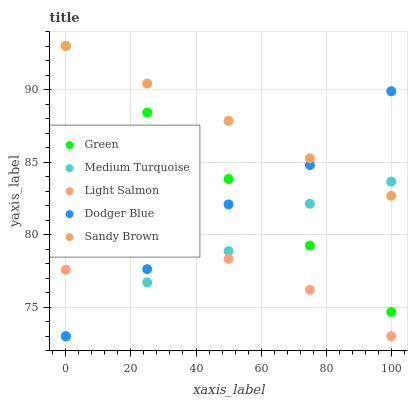Does Light Salmon have the minimum area under the curve?
Answer yes or no. Yes. Does Sandy Brown have the maximum area under the curve?
Answer yes or no. Yes. Does Green have the minimum area under the curve?
Answer yes or no. No. Does Green have the maximum area under the curve?
Answer yes or no. No. Is Sandy Brown the smoothest?
Answer yes or no. Yes. Is Medium Turquoise the roughest?
Answer yes or no. Yes. Is Light Salmon the smoothest?
Answer yes or no. No. Is Light Salmon the roughest?
Answer yes or no. No. Does Dodger Blue have the lowest value?
Answer yes or no. Yes. Does Green have the lowest value?
Answer yes or no. No. Does Sandy Brown have the highest value?
Answer yes or no. Yes. Does Light Salmon have the highest value?
Answer yes or no. No. Is Light Salmon less than Sandy Brown?
Answer yes or no. Yes. Is Sandy Brown greater than Light Salmon?
Answer yes or no. Yes. Does Dodger Blue intersect Light Salmon?
Answer yes or no. Yes. Is Dodger Blue less than Light Salmon?
Answer yes or no. No. Is Dodger Blue greater than Light Salmon?
Answer yes or no. No. Does Light Salmon intersect Sandy Brown?
Answer yes or no. No. 